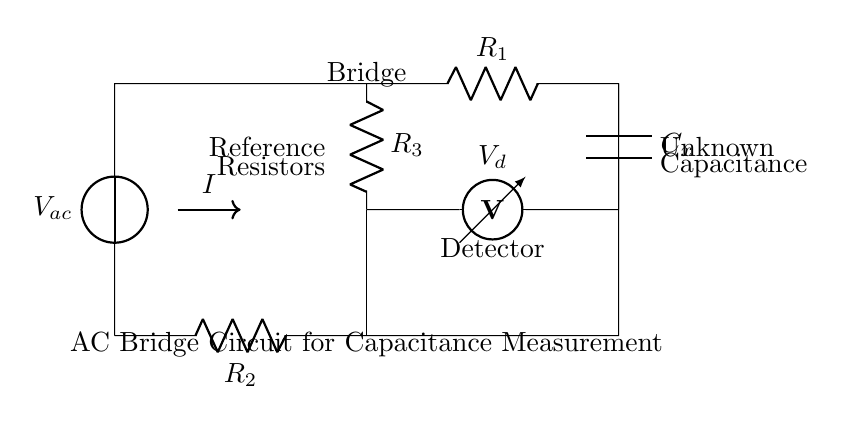What type of circuit is shown? The circuit is an AC bridge circuit, which is indicated by the presence of an AC voltage source and the bridge configuration used for measuring capacitance.
Answer: AC bridge circuit What is the function of the voltmeter in the circuit? The voltmeter measures the potential difference across specific points in the circuit, helping to determine if the bridge is balanced or to find the capacitance value when the bridge is not balanced.
Answer: Measurement How many resistors are present in this circuit? There are three resistors indicated in the circuit diagram, labeled as R1, R2, and R3.
Answer: Three What component is represented by C_x? The component C_x represents the unknown capacitance that is being measured in this AC bridge configuration.
Answer: Unknown capacitance What condition indicates that the bridge is balanced? The bridge is balanced when the voltmeter reads zero volts, meaning there is no potential difference across the meter, indicating that the ratios of resistances and capacitance are equal.
Answer: Zero volts What is the significance of the detector element in this circuit? The detector element, represented in the diagram, is significant as it identifies whether there is a difference in voltage, which is essential for determining the balance and thus the capacitance measurement.
Answer: Voltage detection 